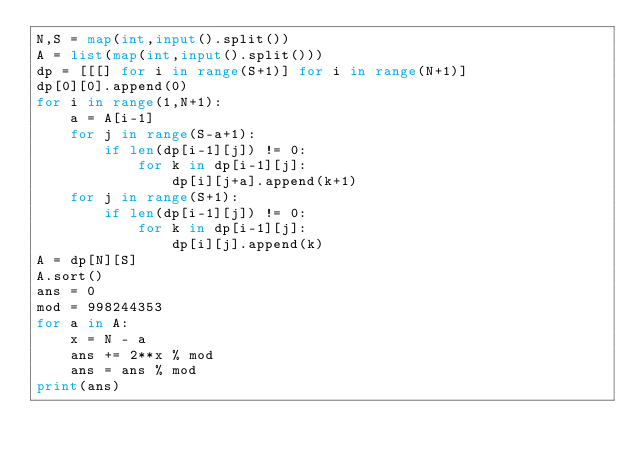Convert code to text. <code><loc_0><loc_0><loc_500><loc_500><_Python_>N,S = map(int,input().split())
A = list(map(int,input().split()))
dp = [[[] for i in range(S+1)] for i in range(N+1)]
dp[0][0].append(0)
for i in range(1,N+1):
    a = A[i-1]
    for j in range(S-a+1):
        if len(dp[i-1][j]) != 0:
            for k in dp[i-1][j]:
                dp[i][j+a].append(k+1)
    for j in range(S+1):
        if len(dp[i-1][j]) != 0:
            for k in dp[i-1][j]:
                dp[i][j].append(k)
A = dp[N][S]
A.sort()
ans = 0
mod = 998244353
for a in A:
    x = N - a
    ans += 2**x % mod
    ans = ans % mod
print(ans)</code> 